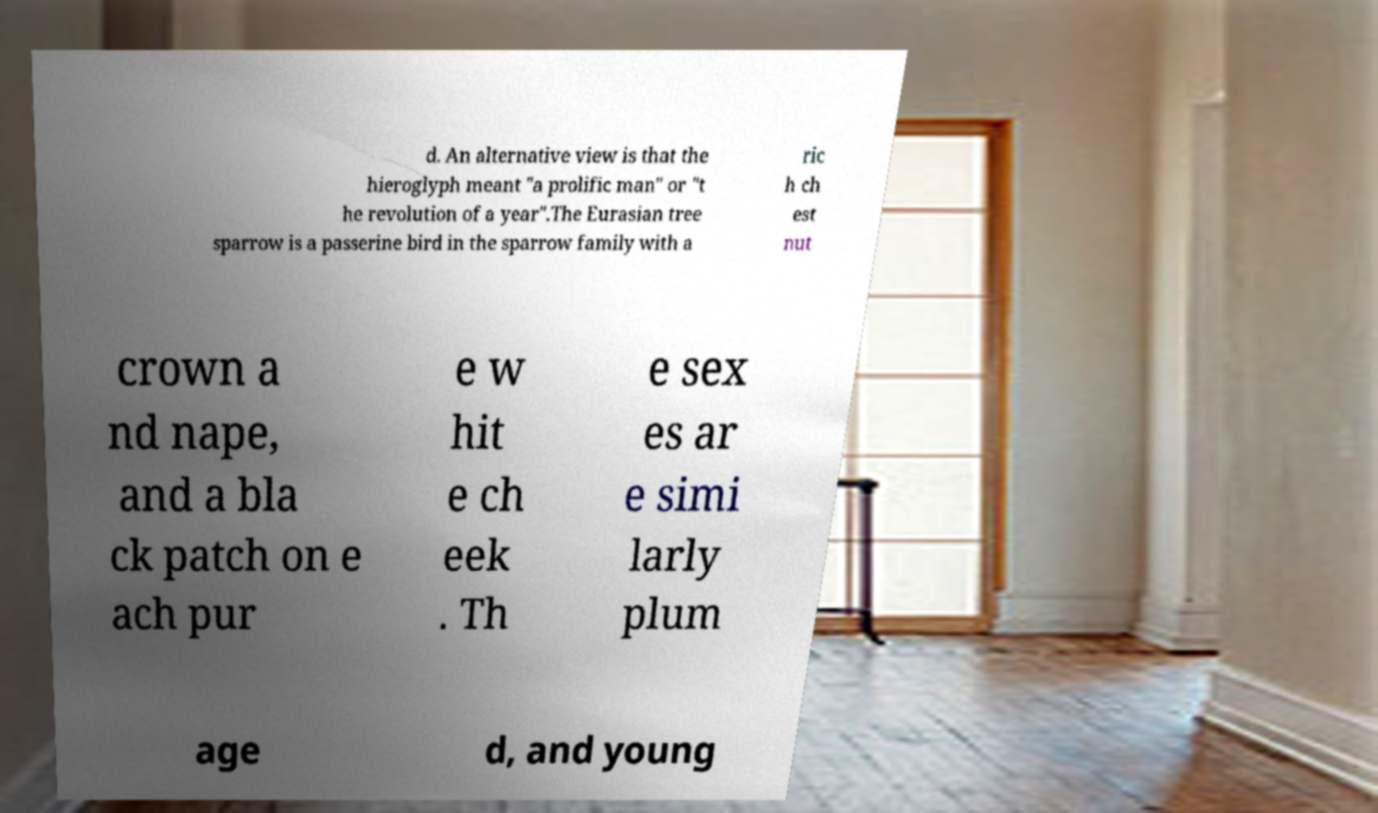Please read and relay the text visible in this image. What does it say? d. An alternative view is that the hieroglyph meant "a prolific man" or "t he revolution of a year".The Eurasian tree sparrow is a passerine bird in the sparrow family with a ric h ch est nut crown a nd nape, and a bla ck patch on e ach pur e w hit e ch eek . Th e sex es ar e simi larly plum age d, and young 